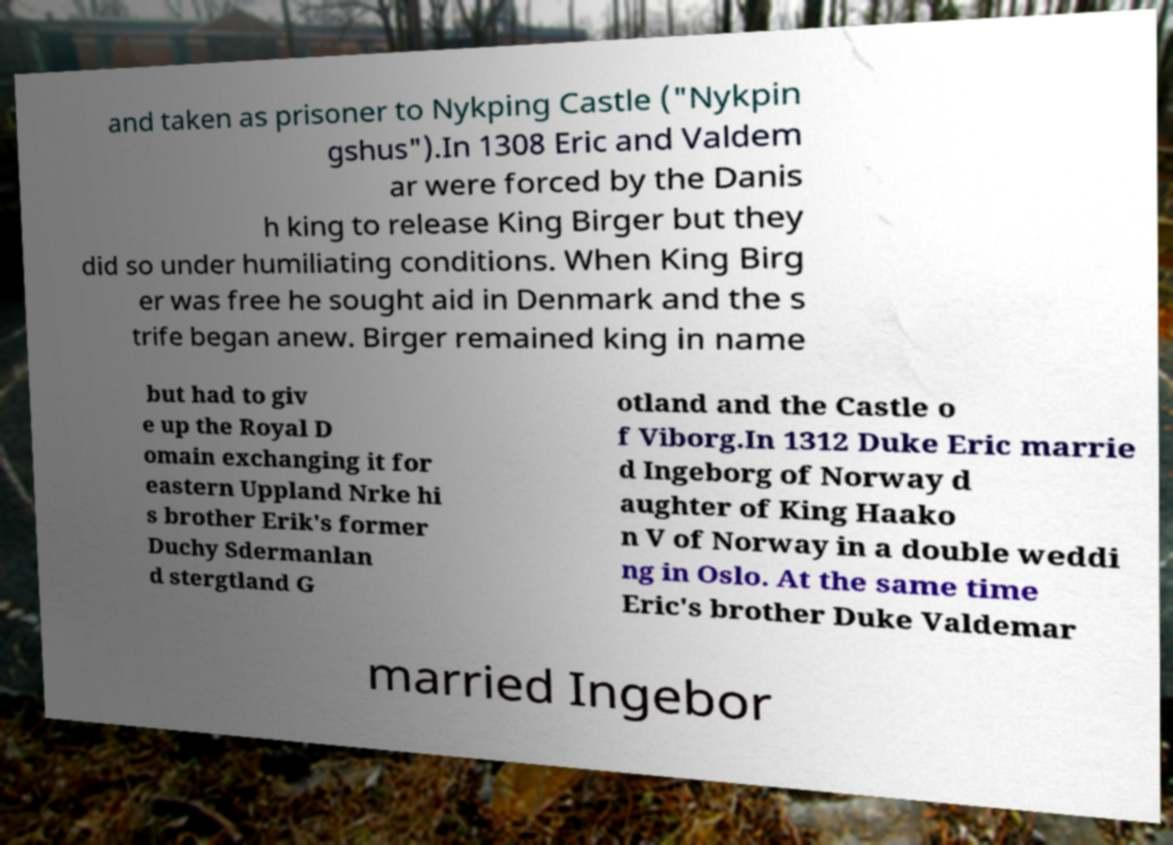I need the written content from this picture converted into text. Can you do that? and taken as prisoner to Nykping Castle ("Nykpin gshus").In 1308 Eric and Valdem ar were forced by the Danis h king to release King Birger but they did so under humiliating conditions. When King Birg er was free he sought aid in Denmark and the s trife began anew. Birger remained king in name but had to giv e up the Royal D omain exchanging it for eastern Uppland Nrke hi s brother Erik's former Duchy Sdermanlan d stergtland G otland and the Castle o f Viborg.In 1312 Duke Eric marrie d Ingeborg of Norway d aughter of King Haako n V of Norway in a double weddi ng in Oslo. At the same time Eric's brother Duke Valdemar married Ingebor 